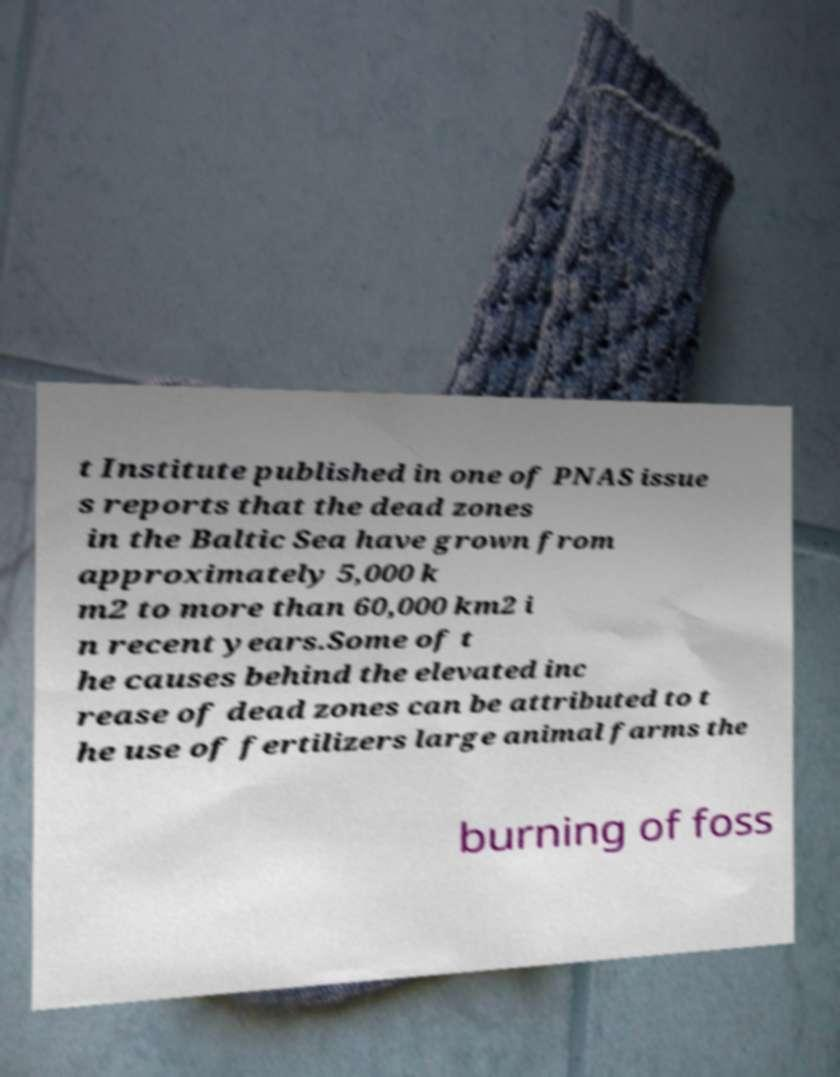What messages or text are displayed in this image? I need them in a readable, typed format. t Institute published in one of PNAS issue s reports that the dead zones in the Baltic Sea have grown from approximately 5,000 k m2 to more than 60,000 km2 i n recent years.Some of t he causes behind the elevated inc rease of dead zones can be attributed to t he use of fertilizers large animal farms the burning of foss 